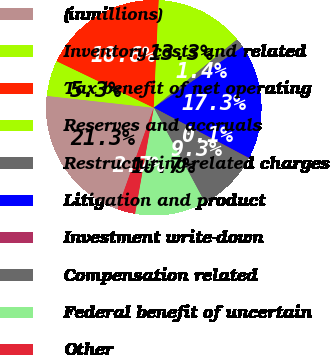Convert chart to OTSL. <chart><loc_0><loc_0><loc_500><loc_500><pie_chart><fcel>(inmillions)<fcel>Inventory costs and related<fcel>Tax benefit of net operating<fcel>Reserves and accruals<fcel>Restructuring-related charges<fcel>Litigation and product<fcel>Investment write-down<fcel>Compensation related<fcel>Federal benefit of uncertain<fcel>Other<nl><fcel>21.28%<fcel>5.35%<fcel>18.63%<fcel>13.32%<fcel>1.37%<fcel>17.3%<fcel>0.05%<fcel>9.34%<fcel>10.66%<fcel>2.7%<nl></chart> 